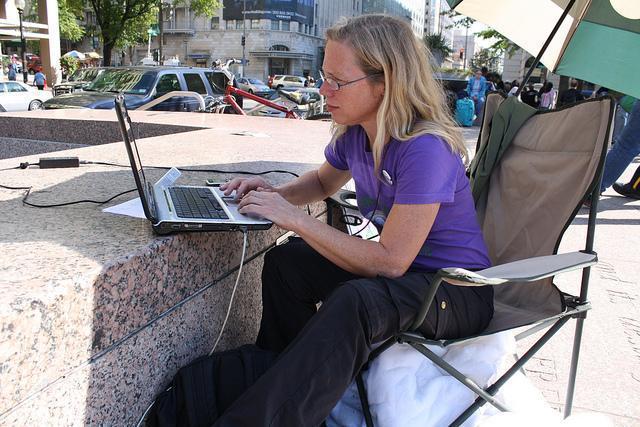Why is she working here?
Answer the question by selecting the correct answer among the 4 following choices.
Options: Left home, sunny outside, power source, is hiding. Power source. 